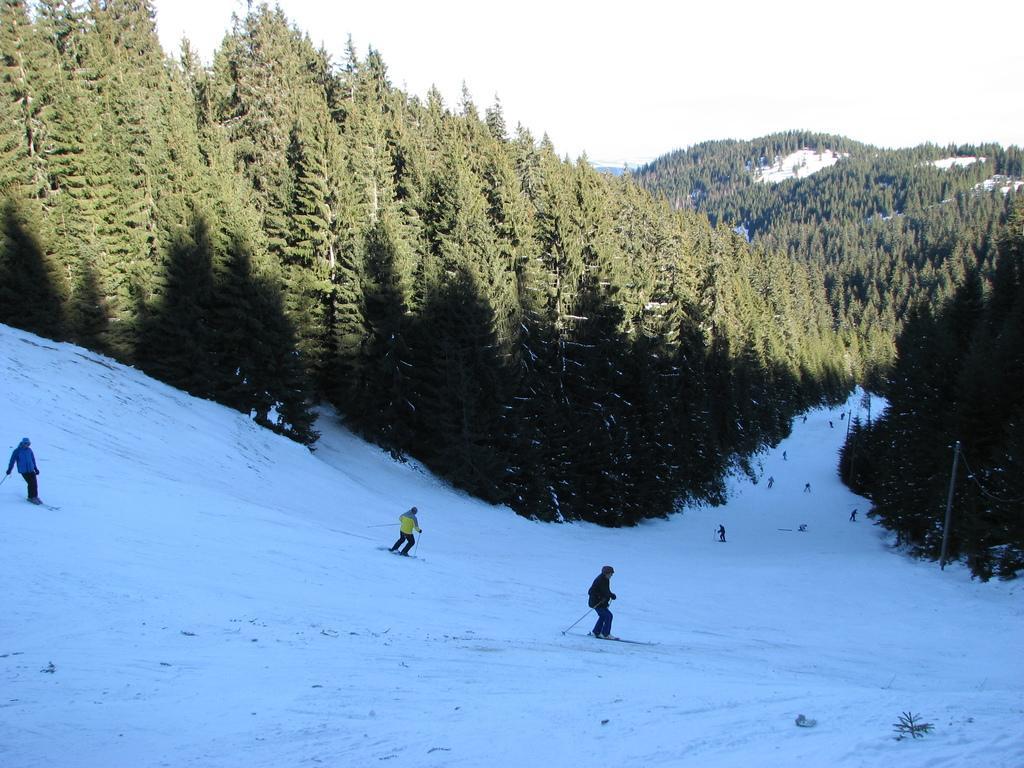Please provide a concise description of this image. In this image I can see a person wearing blue jacket, black pant another person wearing yellow jacket, black pant and other person wearing black color dress are skiing on the snow. In the background I can see few other persons skiing, number of trees which are green in color, few mountains, some snow and the sky. 